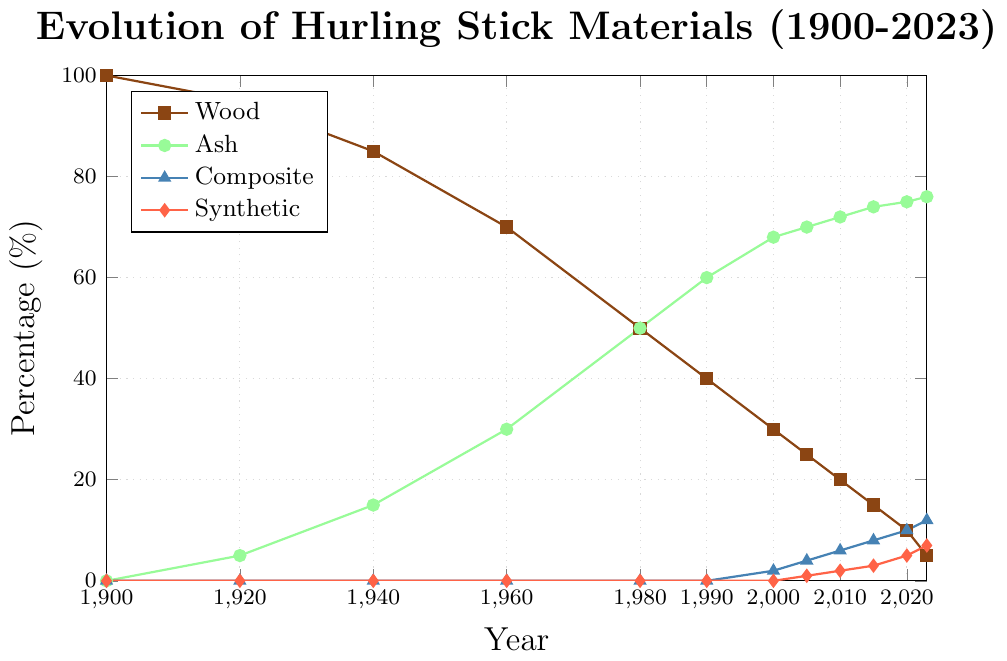Which year had the highest percentage of wood used in hurling sticks? By looking at the plot, it is clear that the line representing wood usage starts at the highest point in 1900 and decreases over time.
Answer: 1900 In which period did the use of synthetic materials in hurling sticks first appear? The plot shows that the line for synthetic materials begins around 2005.
Answer: 2005 How did the percentage of ash used in hurling sticks change from 1940 to 2000? The ash percentage increased steadily over this period: from 15% in 1940 to 68% in 2000.
Answer: Increased from 15% to 68% Compare the percentage of wood and ash used in 1990. Which was higher, and by how much? In 1990, the figure shows wood at 40% and ash at 60%. Ash was higher by 20%.
Answer: Ash by 20% What is the trend in the use of composite materials from 2000 to 2023? The figure shows an increasing trend in composite materials from 2% in 2000 to 12% in 2023.
Answer: Increasing In what year did the percentage of wood drop below 50%? This occurred around 1980, where the wood percentage went from higher to lower than 50%.
Answer: 1980 What were the overall changes in the percentage use of synthetic materials from 2005 to 2023? The figure shows an increase in synthetic materials from 1% in 2005 to 7% in 2023.
Answer: Increased from 1% to 7% What materials became more prominent in the composition of hurling sticks after 1980, and how can you tell? The figure shows an increase in both ash and composite materials after 1980, indicated by rising lines for these materials.
Answer: Ash and composite materials Around what year did wood and ash usage reach equal percentages, and what was that percentage? The plot shows that wood and ash both met at 50% around 1980.
Answer: 1980, 50% By how much did the percentage of wood reduce from 1900 to 2023? The wood percentage decreased from 100% in 1900 to 5% in 2023, a reduction of 95%.
Answer: 95% reduction 